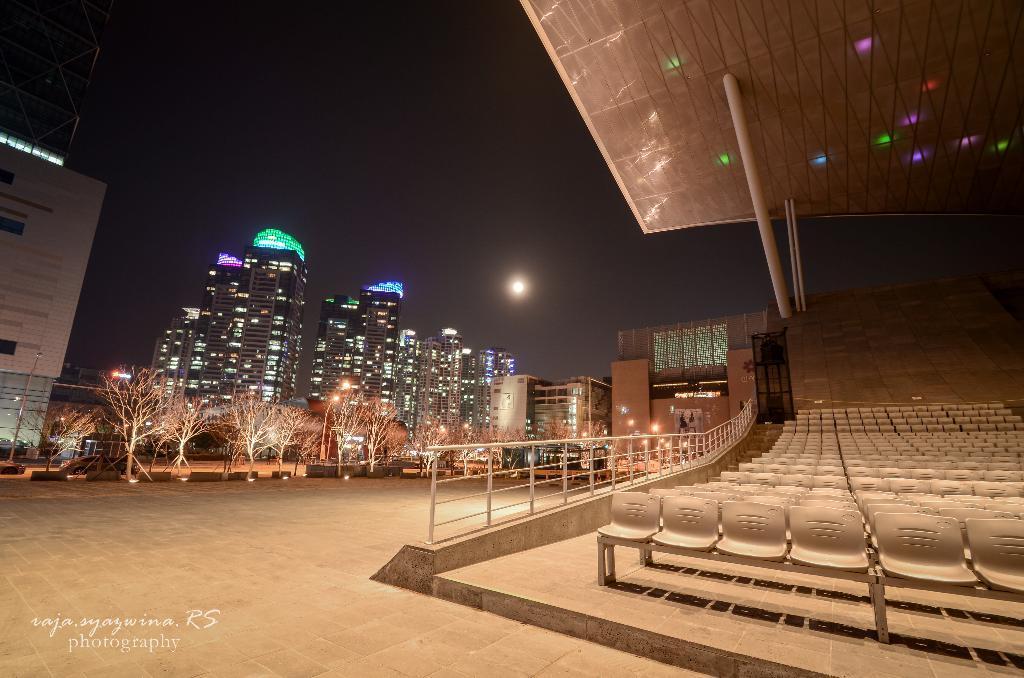Please provide a concise description of this image. In the image we can see there are many tower buildings and trees. Here we can see chairs, fence and pole tent. Here we can see the moon and the dark sky. Here we can see light poles, footpath and in the bottom left we can see water mark. 